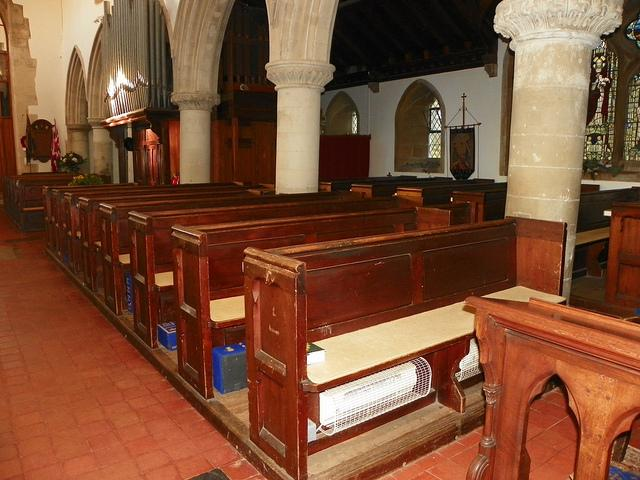What are the objects which are placed underneath the church pews?

Choices:
A) heaters
B) grates
C) storage boxes
D) lights heaters 